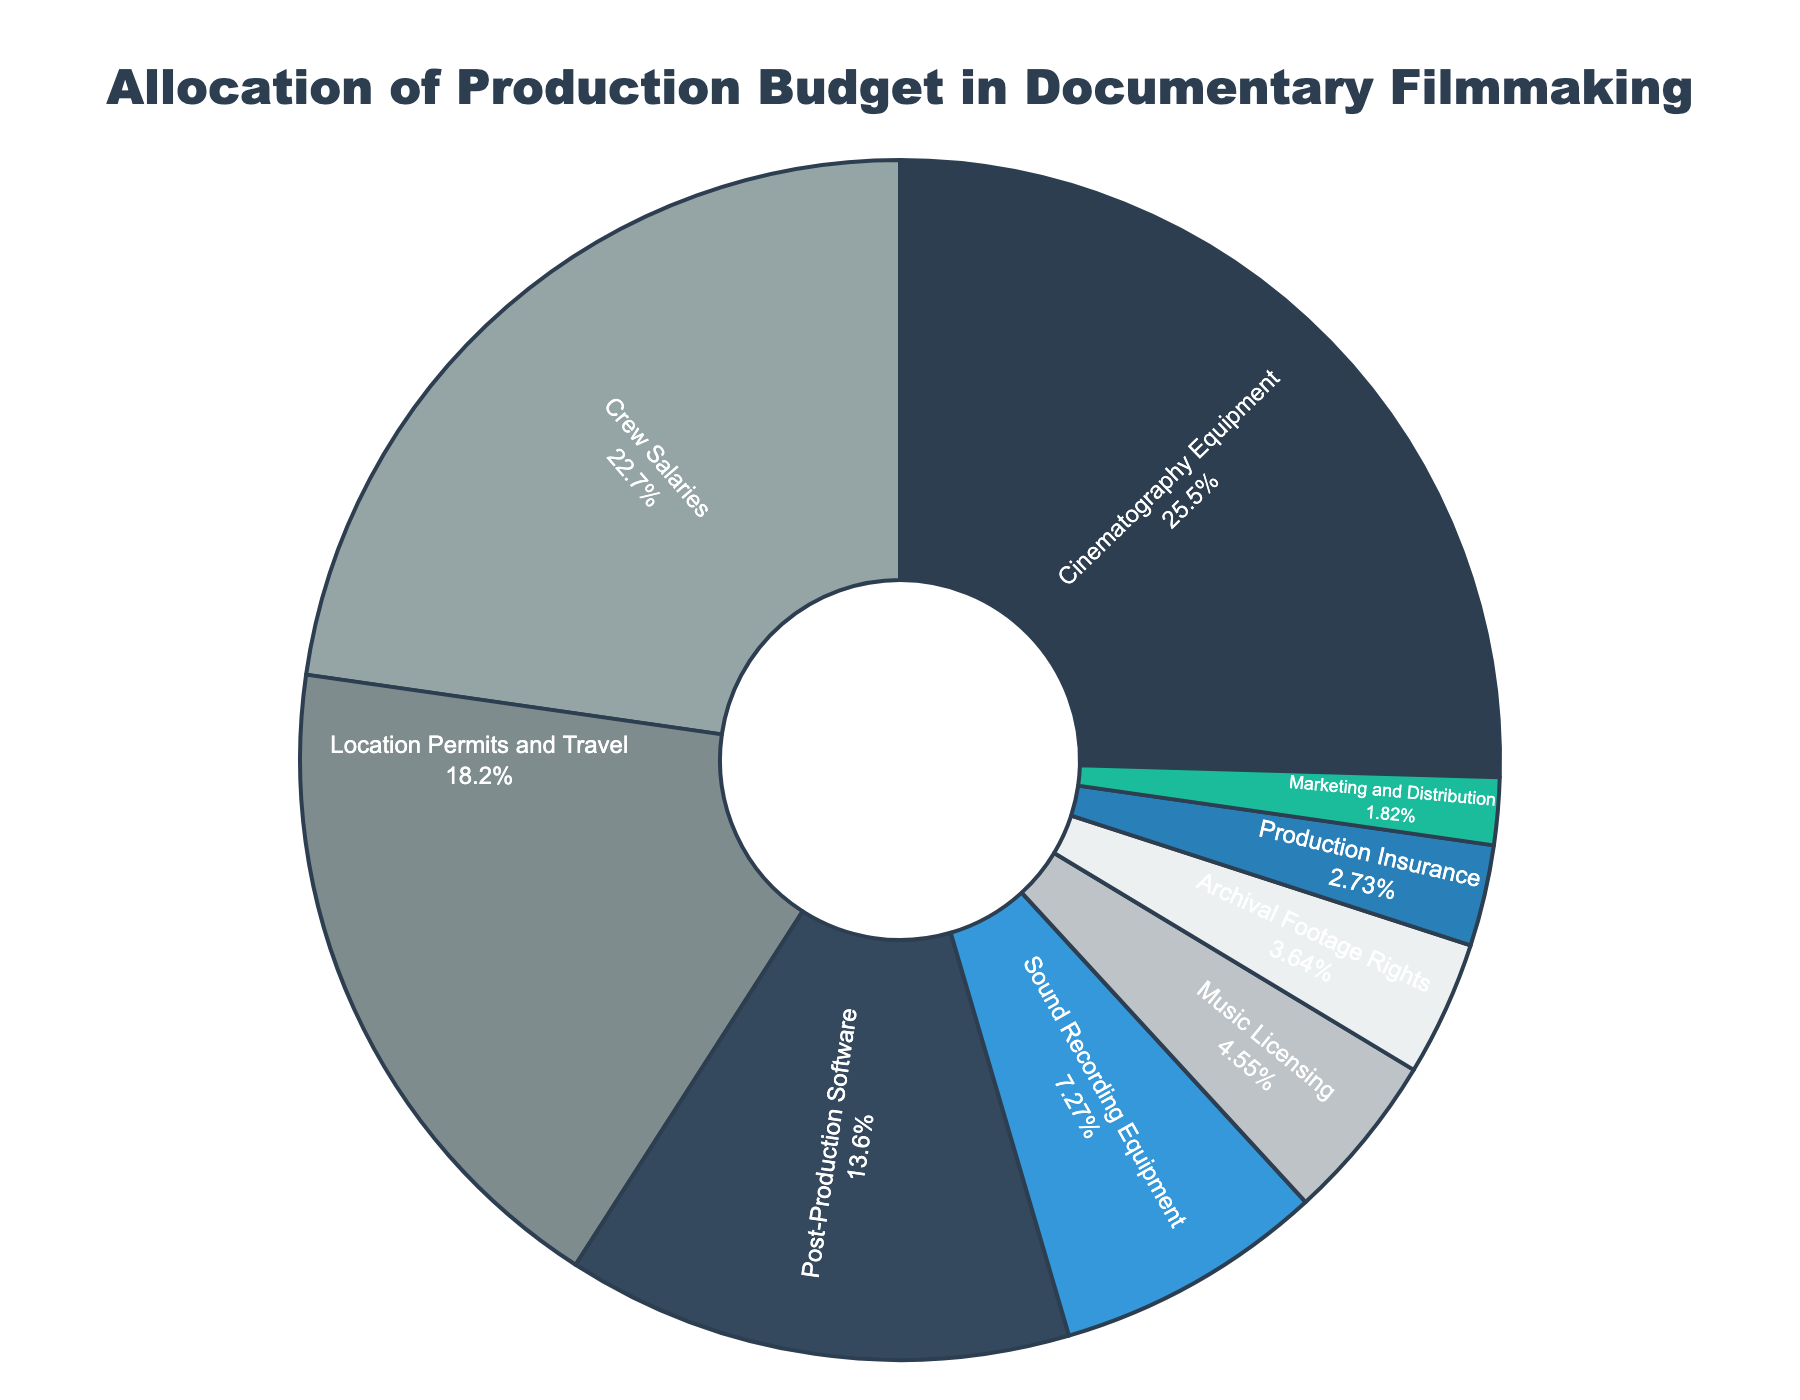what is the largest allocation and its percentage? To find the largest allocation, look for the category with the highest percentage in the pie chart. "Cinematography Equipment" has the highest percentage at 28%.
Answer: Cinematography Equipment, 28% what are the combined allocations for post-production software and crew salaries? Add the percentages of "Post-Production Software" (15%) and "Crew Salaries" (25%). 15% + 25% = 40%.
Answer: 40% Which has a higher allocation: sound recording equipment or archival footage rights? Compare the percentages of "Sound Recording Equipment" (8%) and "Archival Footage Rights" (4%). Since 8% is greater than 4%, "Sound Recording Equipment" has a higher allocation.
Answer: Sound Recording Equipment How does the allocation of crew salaries compare to marketing and distribution? "Crew Salaries" have a 25% allocation while "Marketing and Distribution" have a 2% allocation. 25% is significantly greater than 2%.
Answer: Crew Salaries have a higher allocation What is the net difference between the location permits and travel budget and the marketing and distribution budget? Subtract the percentage of "Marketing and Distribution" (2%) from "Location Permits and Travel" (20%). 20% - 2% = 18%.
Answer: 18% What is the average allocation of music licensing, archival footage rights, and production insurance? Add the percentages of "Music Licensing" (5%), "Archival Footage Rights" (4%), and "Production Insurance" (3%) and then divide by 3. (5% + 4% + 3%) / 3 = 4%.
Answer: 4% Which category has almost the same allocation as the combined allocation for sound recording equipment and production insurance? Combine the percentages of "Sound Recording Equipment" (8%) and "Production Insurance" (3%), which gives 11%. Comparing this to the categories, none are exactly 11%, but "Post-Production Software" is closest with 15%.
Answer: Post-Production Software Can you identify the categories that, combined, make up more than half of the budget? The combined allocations of "Cinematography Equipment" (28%), "Location Permits and Travel" (20%), and "Crew Salaries" (25%) add up to 28% + 20% + 25% = 73%, which is more than half of the budget.
Answer: Cinematography Equipment, Location Permits and Travel, Crew Salaries What percentage of the total budget is allocated to equipment (cinematography and sound recording)? Add the percentages of "Cinematography Equipment" (28%) and "Sound Recording Equipment" (8%). 28% + 8% = 36%.
Answer: 36% What is the least funded category and its percentage? Look for the category with the smallest section in the pie chart, which is "Marketing and Distribution" with a percentage of 2%.
Answer: Marketing and Distribution, 2% 